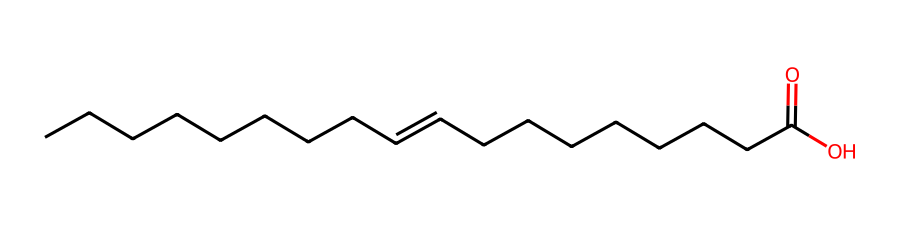What is the functional group present in this compound? The presence of the -COOH group indicates it's a carboxylic acid. In the SMILES notation, the (C(=O)O) part corresponds to the carboxylic acid functional group.
Answer: carboxylic acid How many carbon atoms are in this molecule? By counting the carbon atoms in the SMILES notation, there are 21 carbon atoms total — 9 in the first chain and 9 in the second chain, plus 1 in the carboxylic acid.
Answer: 21 What type of isomerism is exhibited by this compound? The presence of a double bond and differing spatial arrangements around that bond indicates geometric (cis-trans) isomerism.
Answer: geometric (cis-trans) isomerism Which segment of the molecule is involved in geometric isomerism? The double bond between the carbon atoms creates the potential for cis-trans isomerism because it restricts rotation.
Answer: double bond What would the cis configuration look like for this compound? The cis configuration would have the carboxylic acid group on the same side of the double bond, making it spatially distinct compared to the trans configuration, where they would be on opposite sides.
Answer: carboxylic acid on the same side How many geometric isomers can this compound potentially have? There can be two geometric isomers (cis and trans), as it contains only one double bond where isomerism can occur.
Answer: two What property of this compound makes it useful in thermal energy storage? The presence of a carboxylic acid allows for potentially desirable phase-change characteristics, like heat absorption and release during phase transitions.
Answer: phase-change characteristics 